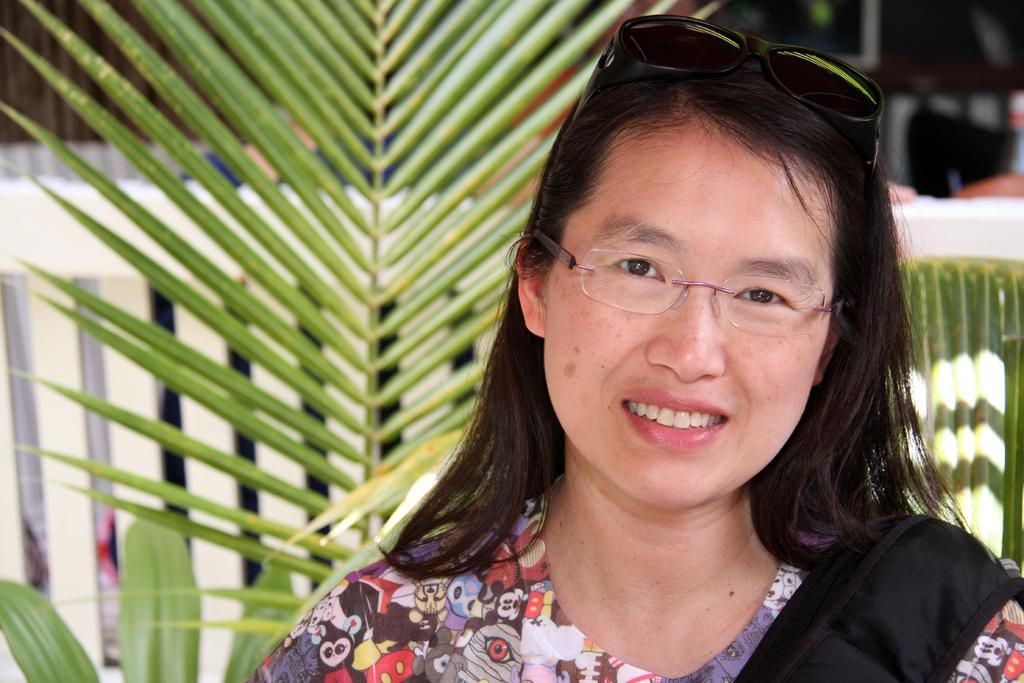What is the main subject of the image? The main subject of the image is a woman. What can be observed about the woman's appearance? The woman is wearing spectacles. What type of natural elements can be seen in the image? There are plants visible on the backside of the image. What type of crown is the woman wearing in the image? There is no crown visible in the image; the woman is wearing spectacles. 